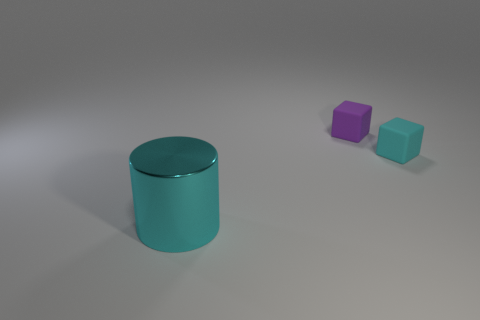Add 1 cylinders. How many objects exist? 4 Subtract all cylinders. How many objects are left? 2 Subtract all large red rubber cylinders. Subtract all metal cylinders. How many objects are left? 2 Add 2 cyan cylinders. How many cyan cylinders are left? 3 Add 1 small cyan cubes. How many small cyan cubes exist? 2 Subtract 0 yellow cylinders. How many objects are left? 3 